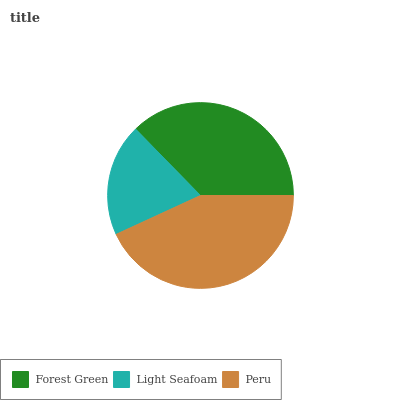Is Light Seafoam the minimum?
Answer yes or no. Yes. Is Peru the maximum?
Answer yes or no. Yes. Is Peru the minimum?
Answer yes or no. No. Is Light Seafoam the maximum?
Answer yes or no. No. Is Peru greater than Light Seafoam?
Answer yes or no. Yes. Is Light Seafoam less than Peru?
Answer yes or no. Yes. Is Light Seafoam greater than Peru?
Answer yes or no. No. Is Peru less than Light Seafoam?
Answer yes or no. No. Is Forest Green the high median?
Answer yes or no. Yes. Is Forest Green the low median?
Answer yes or no. Yes. Is Light Seafoam the high median?
Answer yes or no. No. Is Peru the low median?
Answer yes or no. No. 